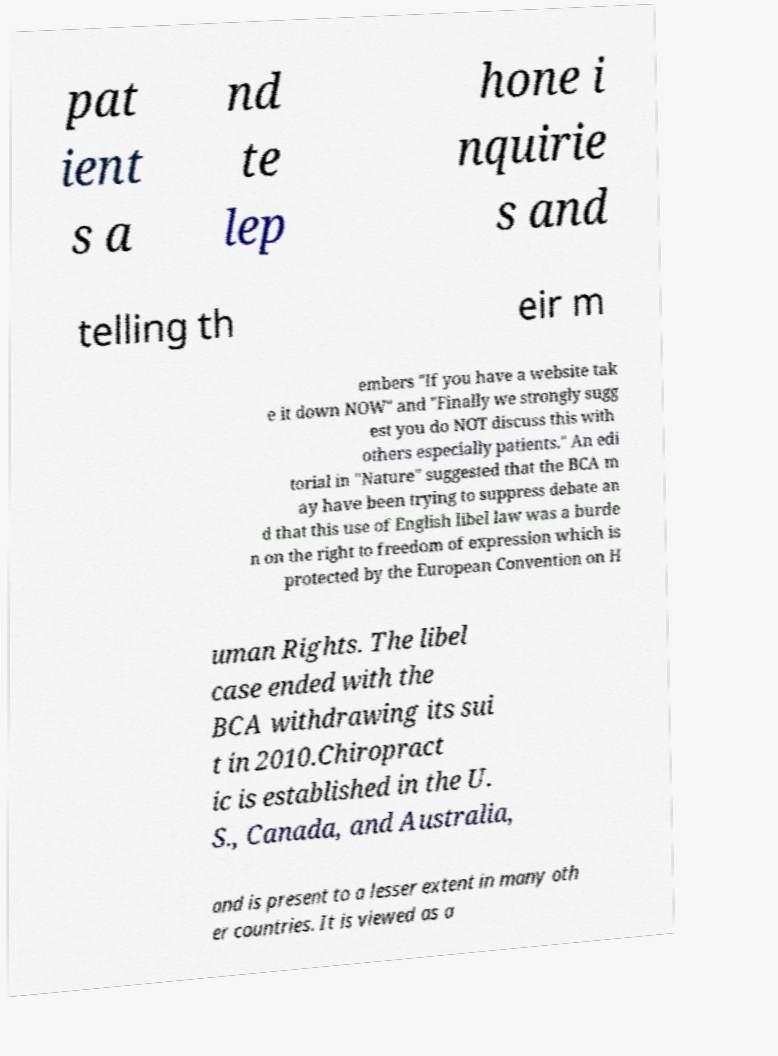Please identify and transcribe the text found in this image. pat ient s a nd te lep hone i nquirie s and telling th eir m embers "If you have a website tak e it down NOW" and "Finally we strongly sugg est you do NOT discuss this with others especially patients." An edi torial in "Nature" suggested that the BCA m ay have been trying to suppress debate an d that this use of English libel law was a burde n on the right to freedom of expression which is protected by the European Convention on H uman Rights. The libel case ended with the BCA withdrawing its sui t in 2010.Chiropract ic is established in the U. S., Canada, and Australia, and is present to a lesser extent in many oth er countries. It is viewed as a 